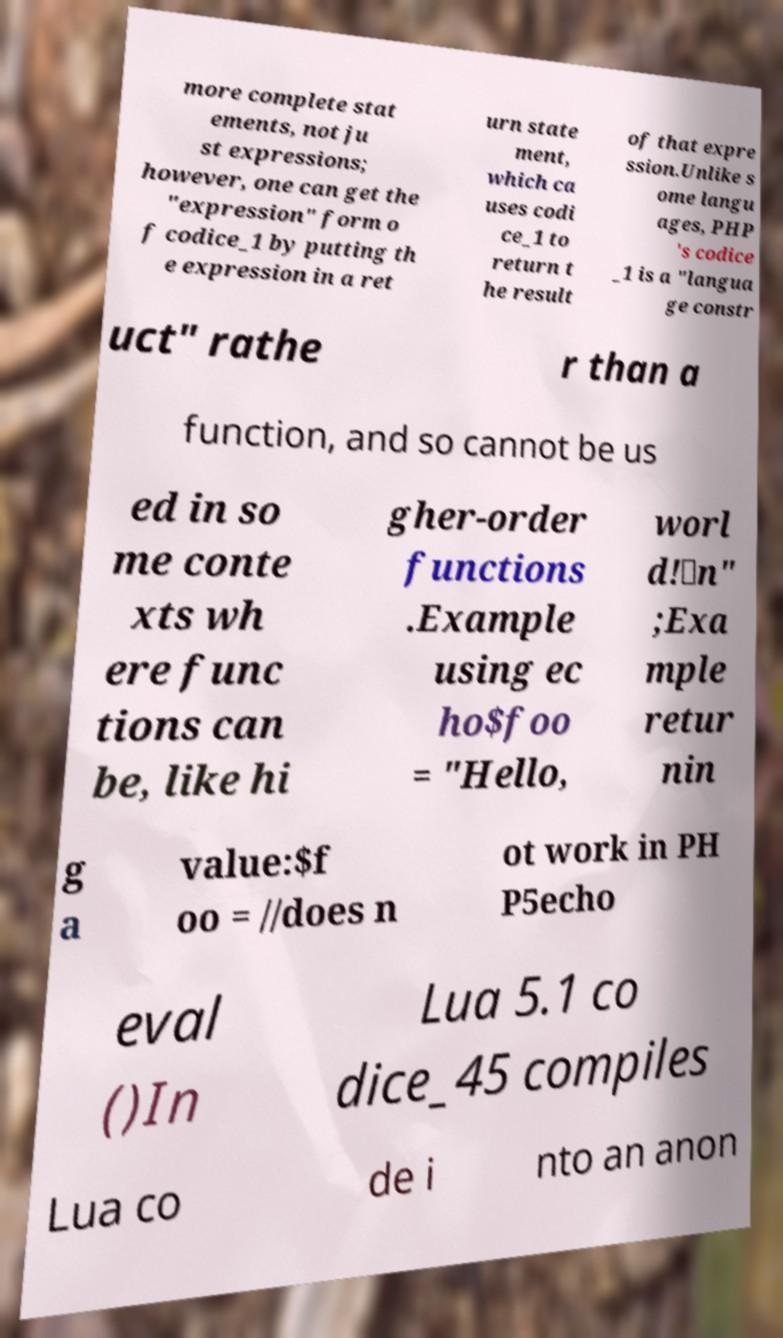Can you accurately transcribe the text from the provided image for me? more complete stat ements, not ju st expressions; however, one can get the "expression" form o f codice_1 by putting th e expression in a ret urn state ment, which ca uses codi ce_1 to return t he result of that expre ssion.Unlike s ome langu ages, PHP 's codice _1 is a "langua ge constr uct" rathe r than a function, and so cannot be us ed in so me conte xts wh ere func tions can be, like hi gher-order functions .Example using ec ho$foo = "Hello, worl d!\n" ;Exa mple retur nin g a value:$f oo = //does n ot work in PH P5echo eval ()In Lua 5.1 co dice_45 compiles Lua co de i nto an anon 